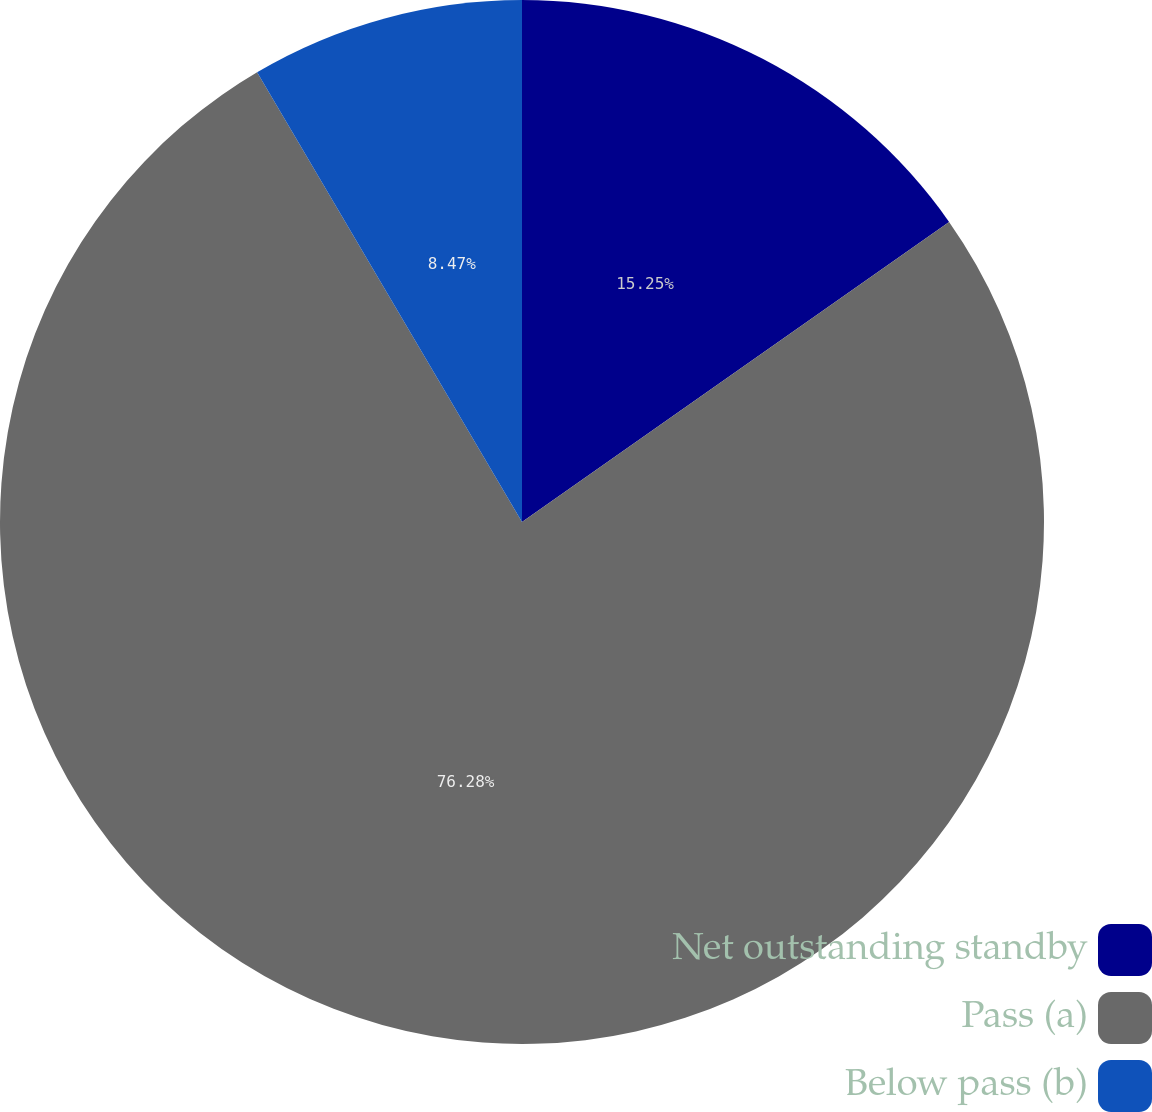<chart> <loc_0><loc_0><loc_500><loc_500><pie_chart><fcel>Net outstanding standby<fcel>Pass (a)<fcel>Below pass (b)<nl><fcel>15.25%<fcel>76.27%<fcel>8.47%<nl></chart> 